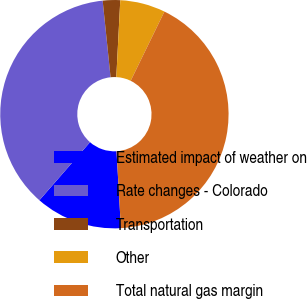Convert chart. <chart><loc_0><loc_0><loc_500><loc_500><pie_chart><fcel>Estimated impact of weather on<fcel>Rate changes - Colorado<fcel>Transportation<fcel>Other<fcel>Total natural gas margin<nl><fcel>12.32%<fcel>36.95%<fcel>2.46%<fcel>6.4%<fcel>41.87%<nl></chart> 